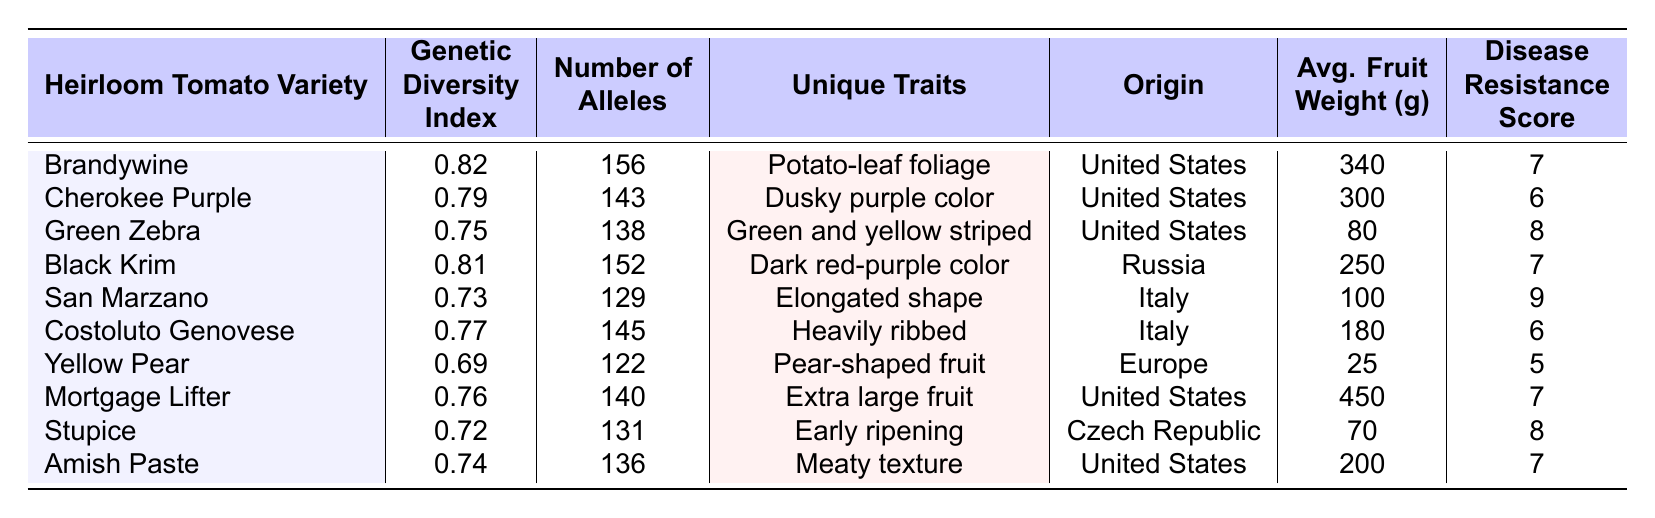What is the genetic diversity index of the Brandywine tomato variety? The table lists the genetic diversity index for Brandywine as 0.82.
Answer: 0.82 Which heirloom tomato variety has the highest average fruit weight? By examining the Avg. Fruit Weight column, Mortgage Lifter has the highest value at 450 grams.
Answer: Mortgage Lifter What is the total number of alleles for the tomato varieties from the United States? Summing the number of alleles for the U.S. varieties: Brandywine (156) + Cherokee Purple (143) + Green Zebra (138) + Mortgage Lifter (140) + Amish Paste (136) = 713.
Answer: 713 Is the Yellow Pear tomato variety more disease-resistant than the San Marzano? Yellow Pear has a disease resistance score of 5, while San Marzano has a score of 9. Therefore, Yellow Pear is not more disease-resistant than San Marzano.
Answer: No Which tomato variety from Italy has the lowest genetic diversity index? The data shows that San Marzano has the lowest genetic diversity index of 0.73 among the varieties from Italy.
Answer: San Marzano What is the average genetic diversity index of all tomato varieties listed? To find the average, sum all genetic diversity indices: 0.82 + 0.79 + 0.75 + 0.81 + 0.73 + 0.77 + 0.69 + 0.76 + 0.72 + 0.74 = 7.78. Divide by 10 to get the average: 7.78 / 10 = 0.778.
Answer: 0.778 Which tomato variety has unique traits of "Early ripening"? The table indicates that the Stupice variety is known for its early ripening trait.
Answer: Stupice Does any heirloom tomato variety have a disease resistance score of 9? Yes, upon checking the Disease Resistance Score column, San Marzano shows a score of 9, confirming the existence of a variety with that score.
Answer: Yes Which tomato variety has both a low average fruit weight and a high disease resistance score? Looking at the table, Yellow Pear has an average fruit weight of 25 grams and a disease resistance score of 5, which is low. Stupice has a weight of 70 grams and a score of 8, which is high. Thus, none meet both criteria.
Answer: None What is the relationship between genetic diversity index and number of alleles for the Black Krim variety? Black Krim has a genetic diversity index of 0.81 and a number of alleles of 152, demonstrating a high diversity index alongside a relatively significant number of alleles.
Answer: High diversity Which heirloom tomato variety is uniquely identified as having "Pear-shaped fruit"? The table clearly states that the Yellow Pear variety is recognized for its unique trait of having a pear-shaped fruit.
Answer: Yellow Pear 